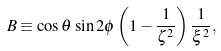<formula> <loc_0><loc_0><loc_500><loc_500>B \equiv \cos \theta \, \sin 2 \phi \left ( 1 - \frac { 1 } { \zeta ^ { 2 } } \right ) \frac { 1 } { \xi ^ { 2 } } ,</formula> 